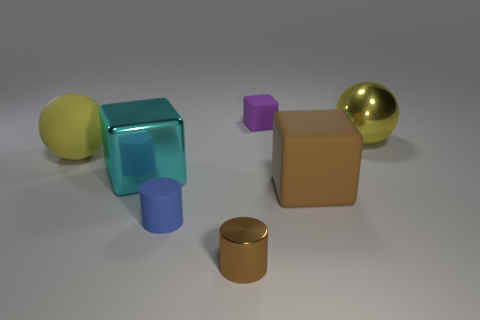Subtract all small blocks. How many blocks are left? 2 Add 2 large yellow things. How many objects exist? 9 Subtract all brown cubes. How many cubes are left? 2 Subtract all cylinders. How many objects are left? 5 Add 2 small cyan matte objects. How many small cyan matte objects exist? 2 Subtract 0 green spheres. How many objects are left? 7 Subtract all yellow blocks. Subtract all red spheres. How many blocks are left? 3 Subtract all big metallic blocks. Subtract all big metal balls. How many objects are left? 5 Add 5 blocks. How many blocks are left? 8 